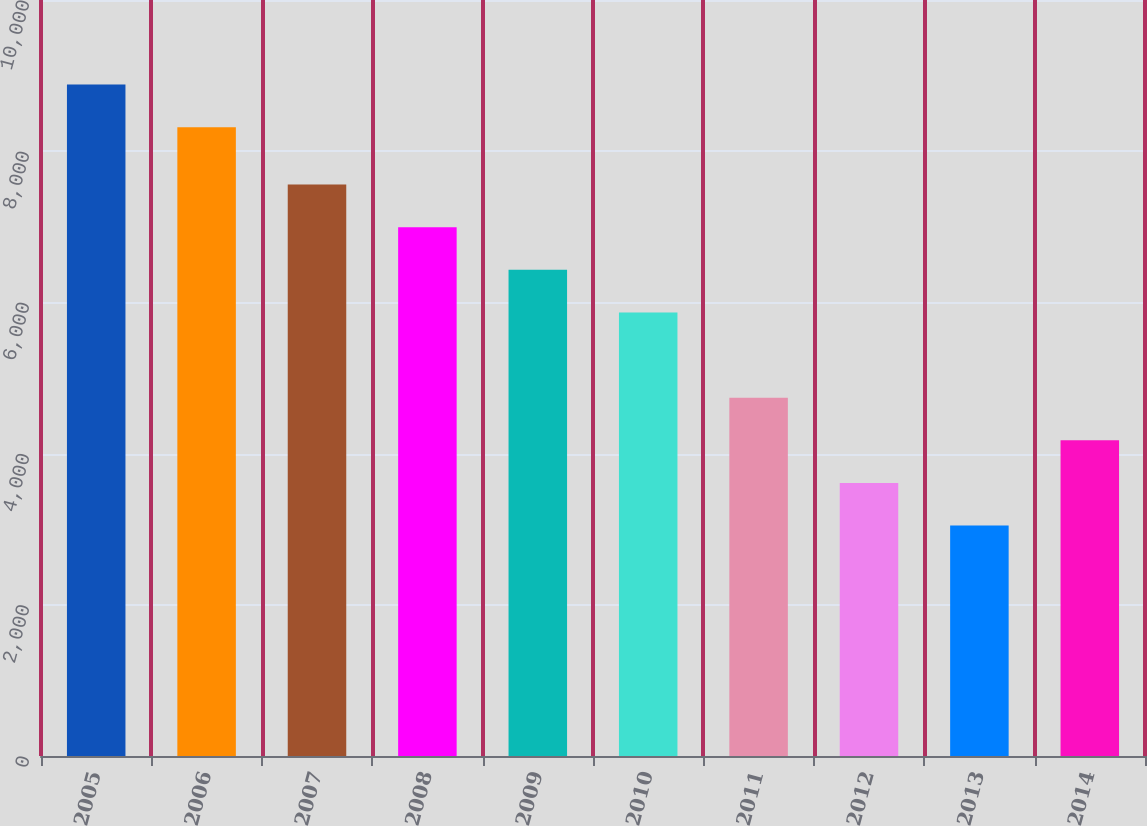Convert chart. <chart><loc_0><loc_0><loc_500><loc_500><bar_chart><fcel>2005<fcel>2006<fcel>2007<fcel>2008<fcel>2009<fcel>2010<fcel>2011<fcel>2012<fcel>2013<fcel>2014<nl><fcel>8881.7<fcel>8318<fcel>7558.6<fcel>6994.9<fcel>6431.2<fcel>5867.5<fcel>4740.1<fcel>3612.7<fcel>3049<fcel>4176.4<nl></chart> 